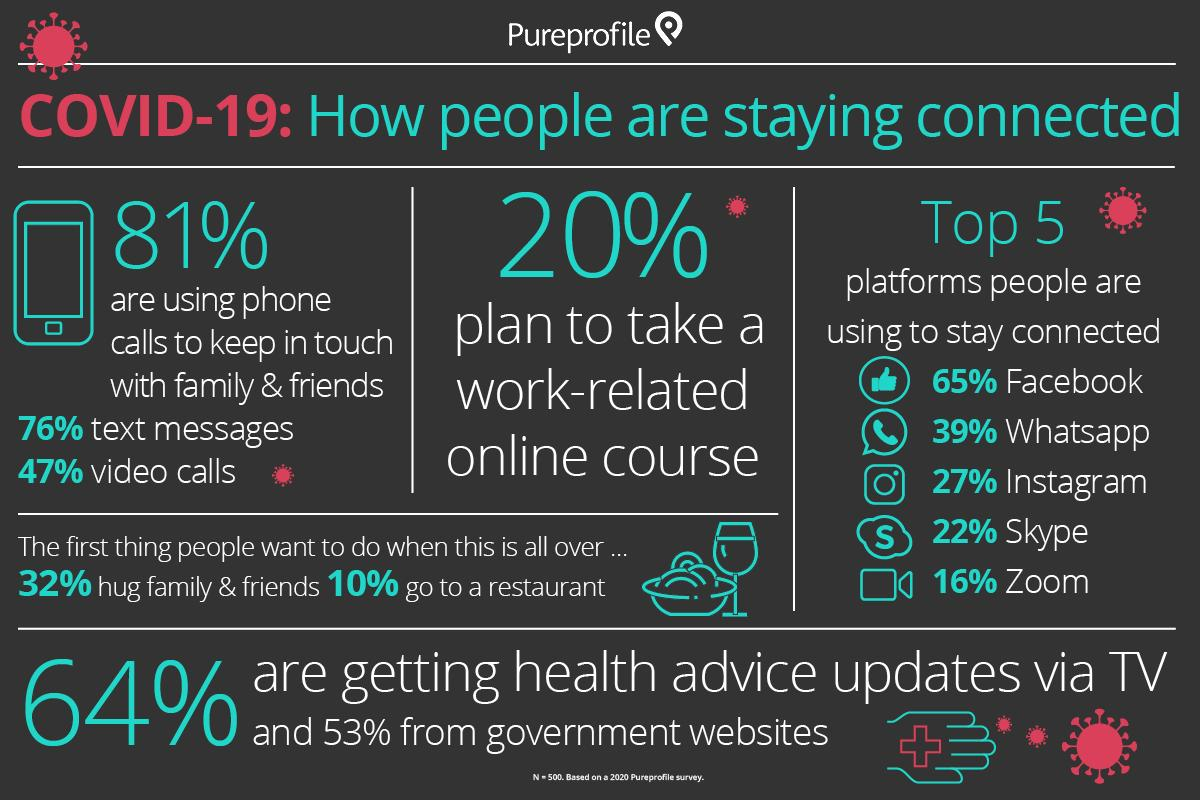Give some essential details in this illustration. Facebook is the most widely used social media platform among the global population to stay connected with family and friends during the COVID-19 pandemic. According to a recent survey, 53% of the world's population are receiving Covid-19 related health advice updates via government websites. According to recent data, Instagram is the third most popular social media platform used by the global population to stay connected with loved ones during the COVID-19 pandemic. During the COVID-19 pandemic, it is estimated that approximately 20% of the world's population took a work-related online course. According to recent data, 64% of the global population is receiving Covid-19 related health advice updates through television. 